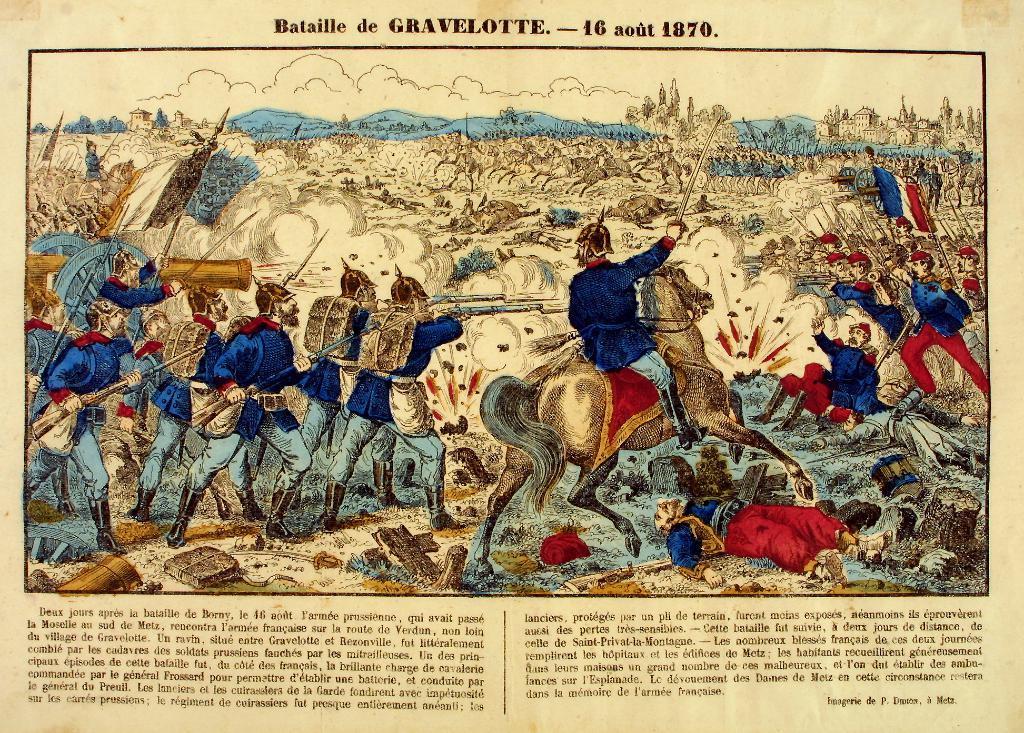Describe this image in one or two sentences. In this picture we can see a paper, in the paper we can find some text and few persons. 